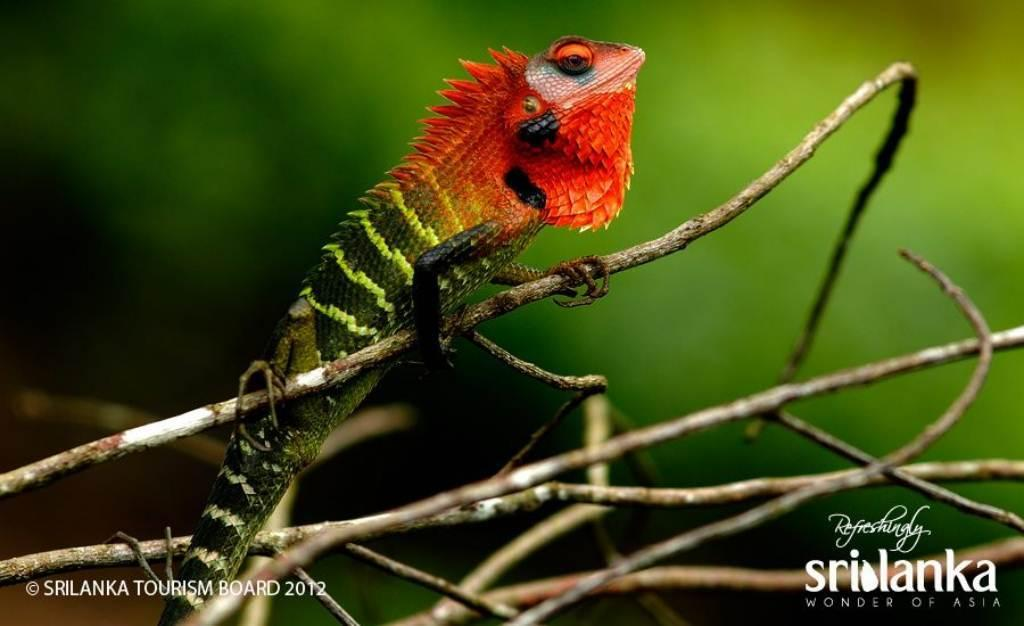What type of animal is in the image? There is an iguana in the image. Where is the iguana located? The iguana is on a branch of a tree. What else can be seen in the image besides the iguana? There is text visible at the bottom of the image. What direction is the scarecrow facing in the image? There is no scarecrow present in the image. What type of scale is used to weigh the iguana in the image? There is no scale present in the image, and the iguana's weight is not mentioned. 